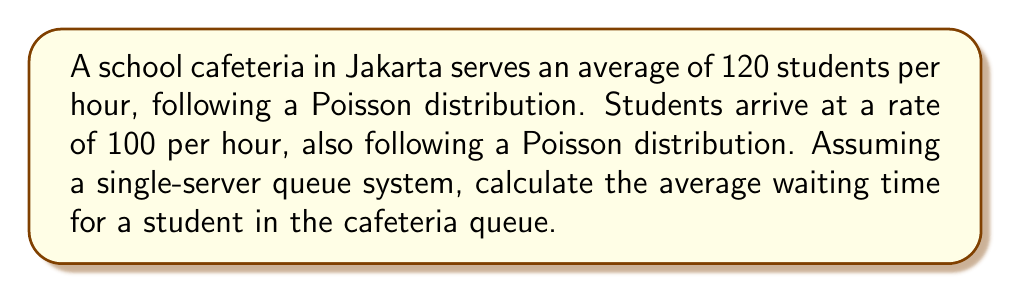What is the answer to this math problem? To solve this problem, we'll use the M/M/1 queueing model, where arrivals and service times follow Poisson distributions. We'll follow these steps:

1. Identify the arrival rate ($\lambda$) and service rate ($\mu$):
   $\lambda = 100$ students/hour
   $\mu = 120$ students/hour

2. Calculate the utilization factor ($\rho$):
   $$\rho = \frac{\lambda}{\mu} = \frac{100}{120} = \frac{5}{6} \approx 0.833$$

3. Calculate the average number of students in the system ($L$):
   $$L = \frac{\rho}{1-\rho} = \frac{5/6}{1-5/6} = 5$$

4. Calculate the average time a student spends in the system ($W$):
   $$W = \frac{L}{\lambda} = \frac{5}{100} = 0.05\text{ hours} = 3\text{ minutes}$$

5. Calculate the average service time ($\frac{1}{\mu}$):
   $$\frac{1}{\mu} = \frac{1}{120} = \frac{1}{2}\text{ minutes}$$

6. Finally, calculate the average waiting time ($W_q$):
   $$W_q = W - \frac{1}{\mu} = 3 - \frac{1}{2} = 2.5\text{ minutes}$$

Therefore, the average waiting time for a student in the cafeteria queue is 2.5 minutes.
Answer: 2.5 minutes 